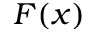Convert formula to latex. <formula><loc_0><loc_0><loc_500><loc_500>F ( x )</formula> 